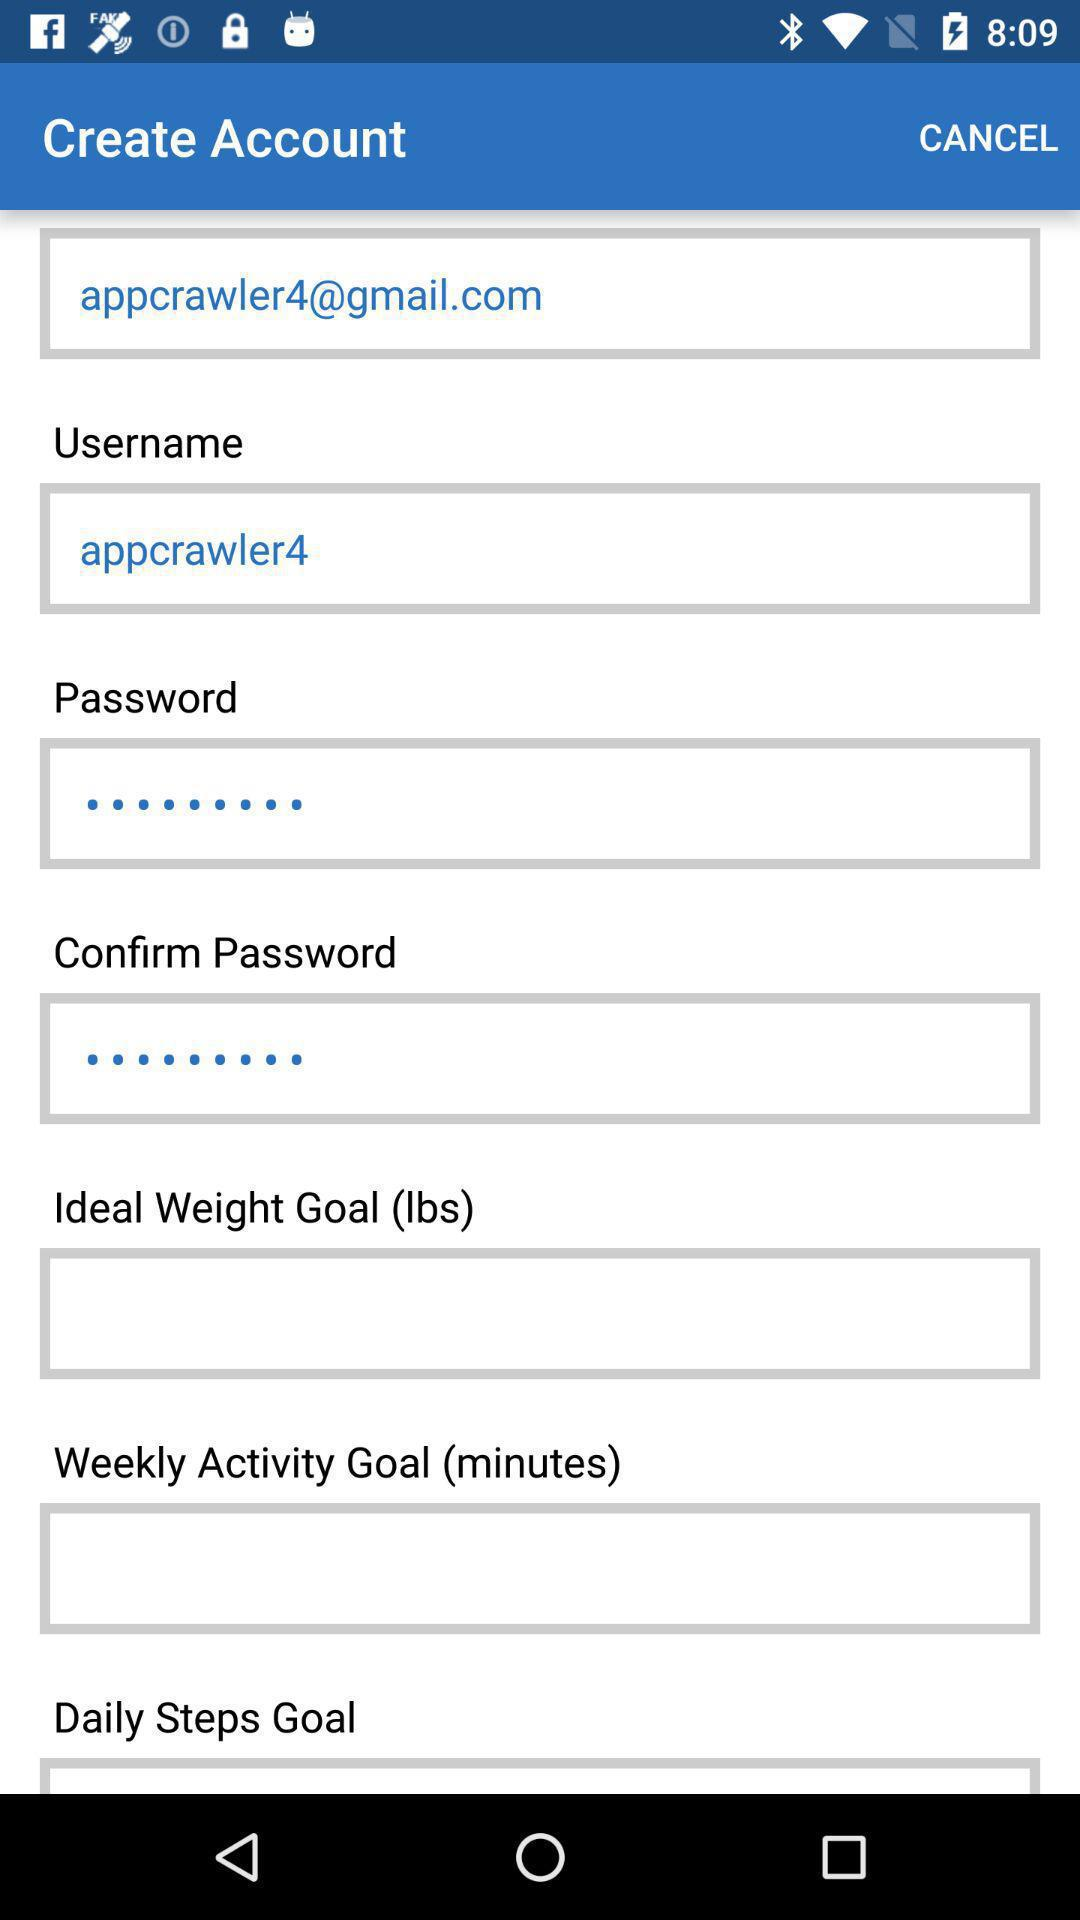What is the email address? The email address is appcrawler4@gmail.com. 